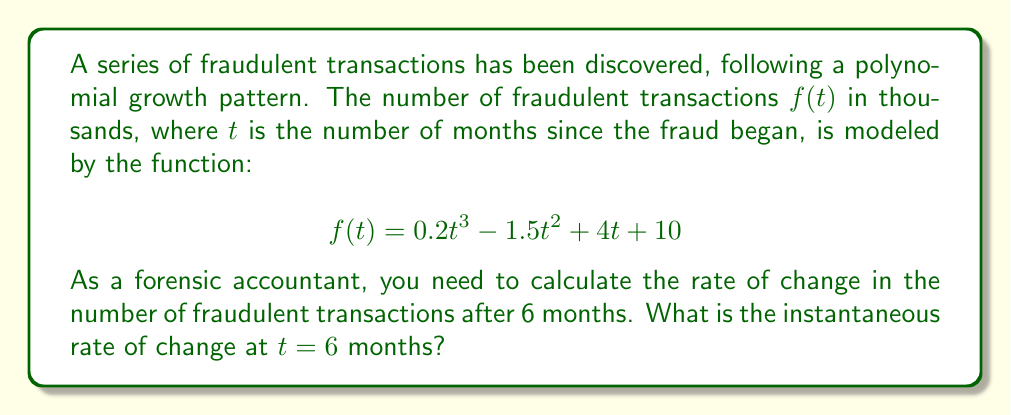Can you solve this math problem? To find the instantaneous rate of change at $t = 6$ months, we need to calculate the derivative of the function $f(t)$ and evaluate it at $t = 6$.

Step 1: Find the derivative of $f(t)$.
$$f(t) = 0.2t^3 - 1.5t^2 + 4t + 10$$
$$f'(t) = 0.6t^2 - 3t + 4$$

Step 2: Evaluate $f'(t)$ at $t = 6$.
$$f'(6) = 0.6(6)^2 - 3(6) + 4$$
$$f'(6) = 0.6(36) - 18 + 4$$
$$f'(6) = 21.6 - 18 + 4$$
$$f'(6) = 7.6$$

The instantaneous rate of change at $t = 6$ months is 7.6 thousand fraudulent transactions per month.
Answer: 7.6 thousand transactions/month 